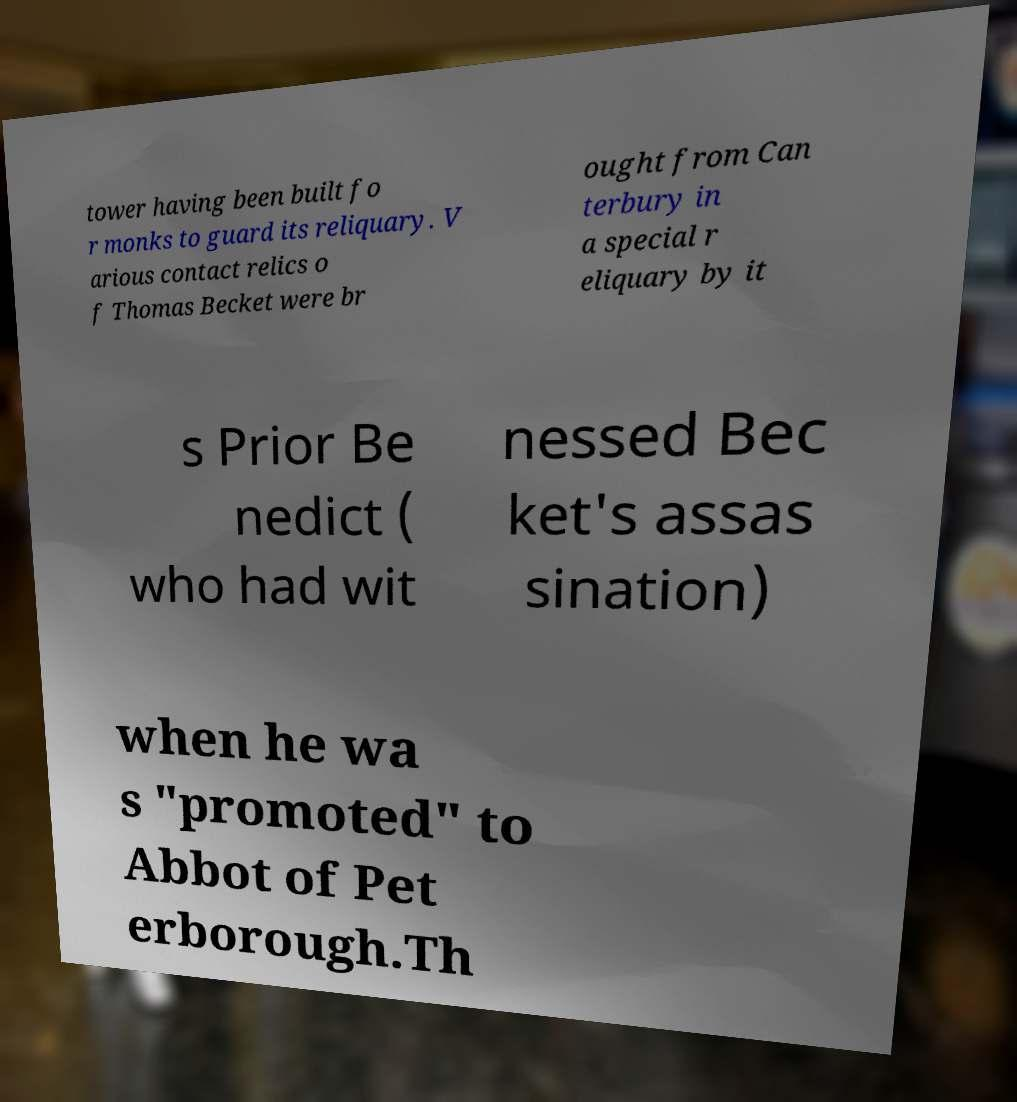For documentation purposes, I need the text within this image transcribed. Could you provide that? tower having been built fo r monks to guard its reliquary. V arious contact relics o f Thomas Becket were br ought from Can terbury in a special r eliquary by it s Prior Be nedict ( who had wit nessed Bec ket's assas sination) when he wa s "promoted" to Abbot of Pet erborough.Th 